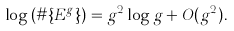Convert formula to latex. <formula><loc_0><loc_0><loc_500><loc_500>\log \left ( \# \{ E ^ { g } \} \right ) = g ^ { 2 } \log g + O ( g ^ { 2 } ) .</formula> 